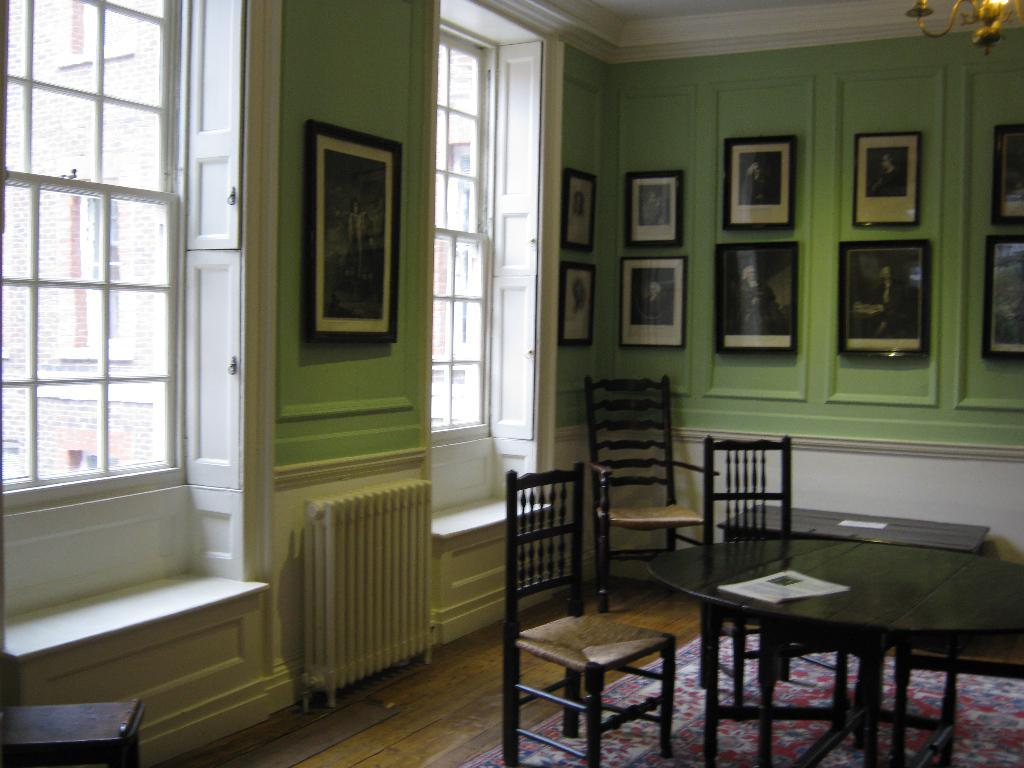What type of furniture can be seen in the image? There are chairs and tables in the image. What objects are present on the tables? Papers are present on the tables in the image. What type of lighting fixture is visible in the image? There is a chandelier in the image. What is attached to the wall in the image? There are frames attached to the wall in the image. What architectural feature is present in the image? There are windows in the image. What can be inferred about the setting of the image? The background of the image appears to be a building. How many boys are playing with the uncle in the image? There are no boys or uncles present in the image. What type of truck is parked outside the building in the image? There is no truck visible in the image; it only shows the interior of a room with furniture and decorations. 